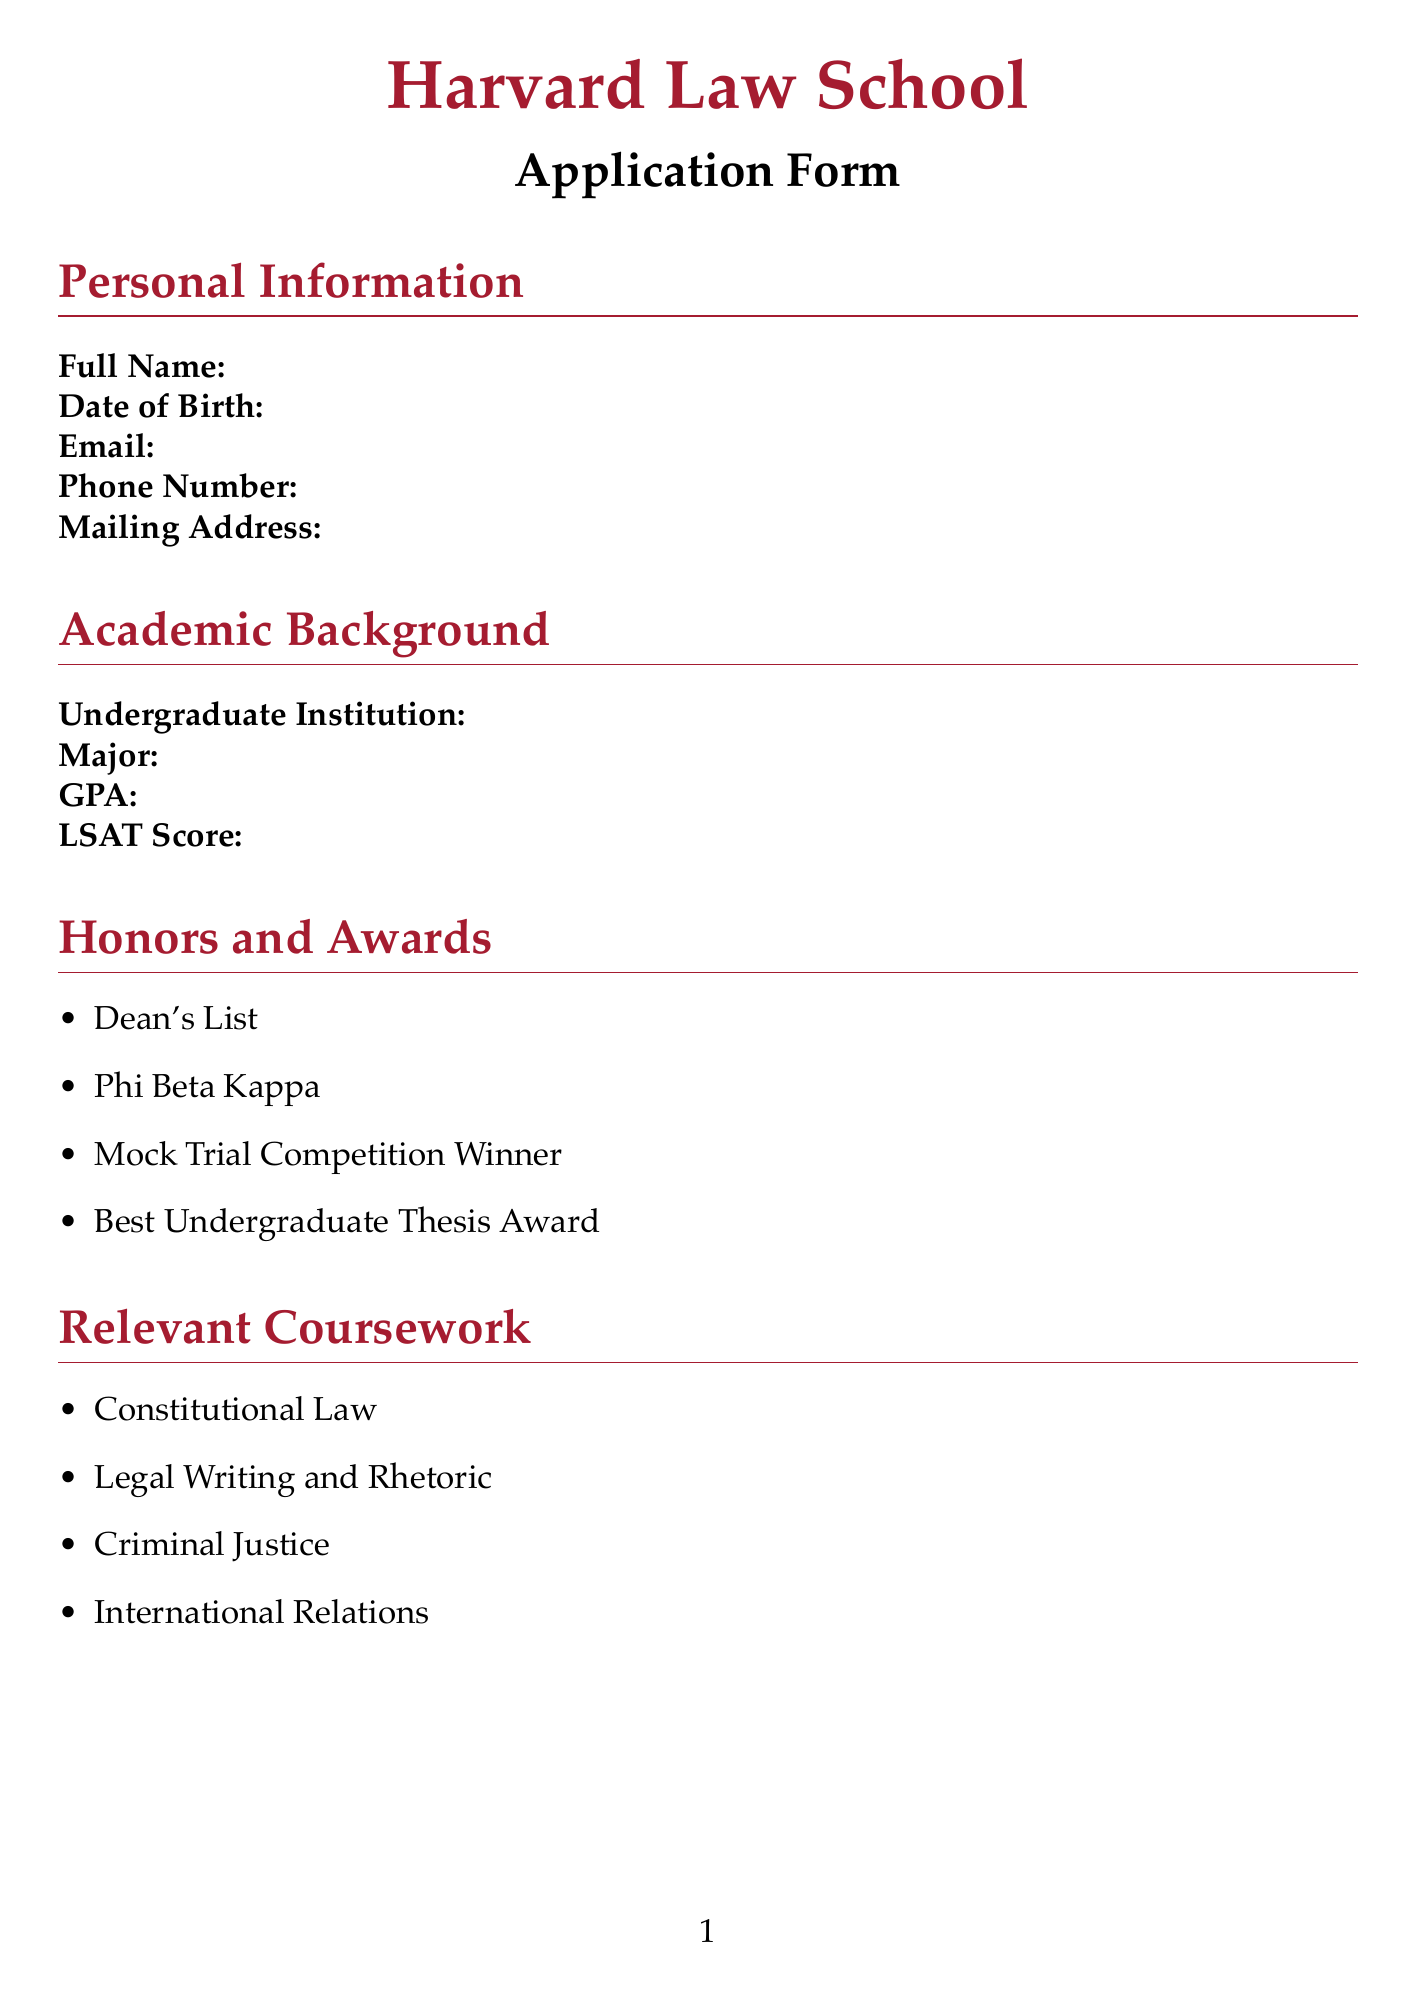What is the full title of the application form? The title at the top of the document indicates it is the Harvard Law School Application Form.
Answer: Harvard Law School Application Form What position did the applicant hold at the law firm? The work experience section lists "Legal Intern" as the applicant's position at Smith & Associates Law Firm.
Answer: Legal Intern How many letters of recommendation are required? The letters of recommendation section states that 2 recommendations are required.
Answer: 2 What is the character limit for the additional information section? The additional information section specifies a character limit to ensure concise responses.
Answer: 1000 What is one of the honors and awards listed in the document? The honors and awards section lists multiple accomplishments, one of which includes "Best Undergraduate Thesis Award."
Answer: Best Undergraduate Thesis Award What professional goal is suggested to discuss in the personal statement? The personal statement guidelines encourage discussing long-term career aspirations in the legal field.
Answer: Long-term career aspirations What extracurricular activity did the applicant serve as president? The extracurricular activities section notes that the applicant was the president of the Pre-Law Society.
Answer: Pre-Law Society President What is the prompt for the diversity statement? The diversity statement section provides a specific prompt for applicants to answer about their background and contributions.
Answer: In 250-500 words, describe how your background, experiences, and perspectives will contribute to the diversity of the Harvard Law School community 